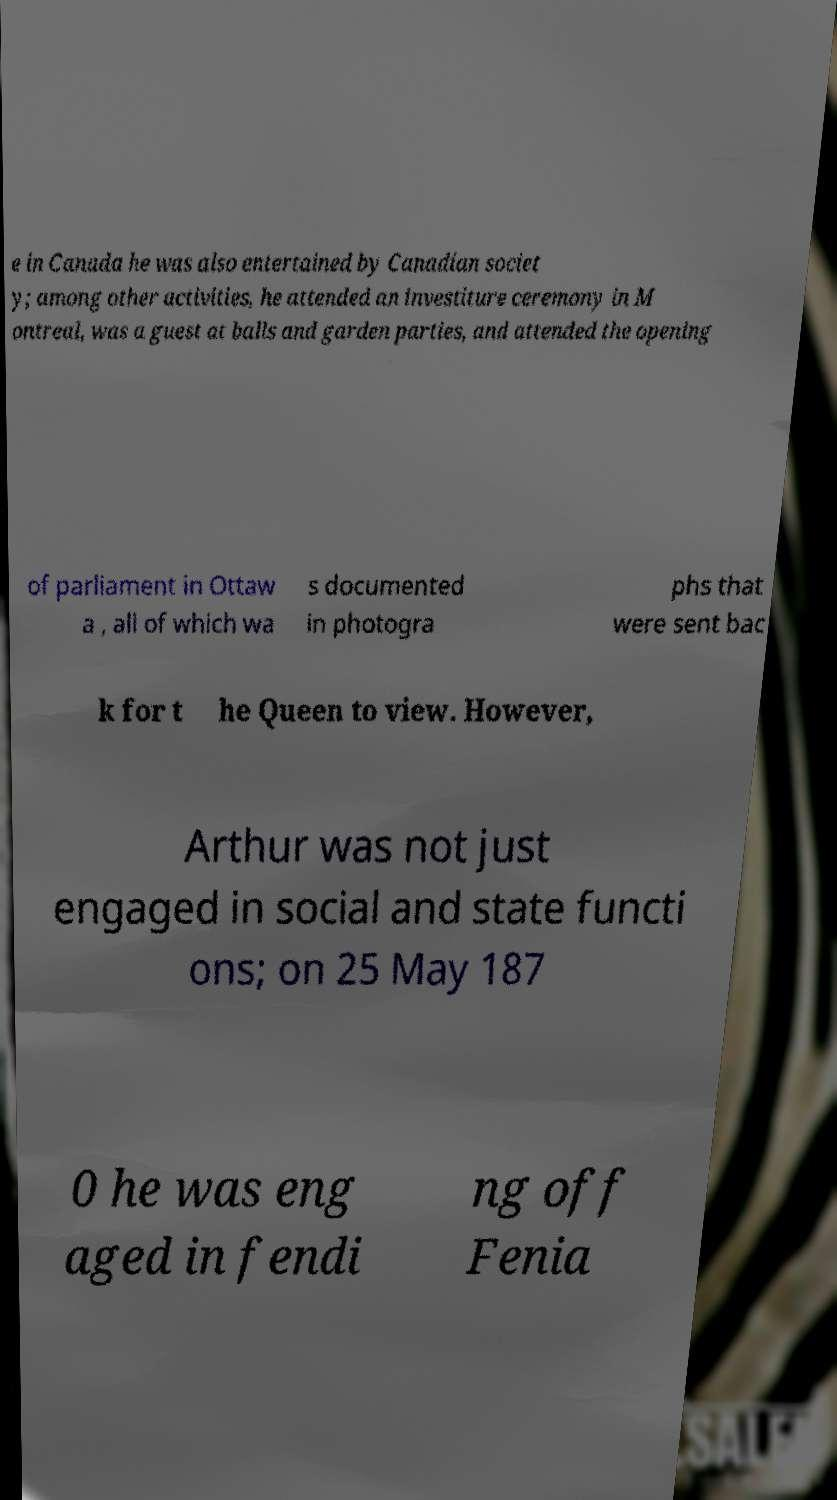Please identify and transcribe the text found in this image. e in Canada he was also entertained by Canadian societ y; among other activities, he attended an investiture ceremony in M ontreal, was a guest at balls and garden parties, and attended the opening of parliament in Ottaw a , all of which wa s documented in photogra phs that were sent bac k for t he Queen to view. However, Arthur was not just engaged in social and state functi ons; on 25 May 187 0 he was eng aged in fendi ng off Fenia 